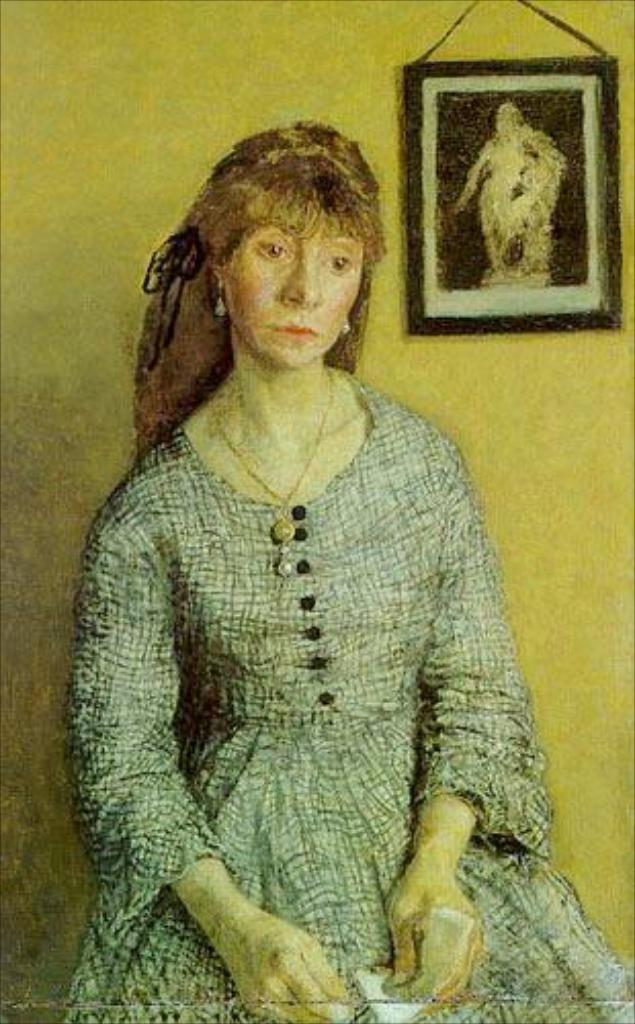What type of artwork is depicted in the image? The image is a painting. What is the main subject of the painting? There is a woman sitting in the image. Where is the woman located in relation to the wall? The woman is near a wall in the image. What can be seen on the wall in the painting? There is a photo frame on the wall in the image. How many yaks are visible in the painting? There are no yaks present in the painting; it features a woman sitting near a wall with a photo frame. What time of day is depicted in the painting? The painting does not provide information about the time of day; it only shows a woman sitting near a wall with a photo frame. 